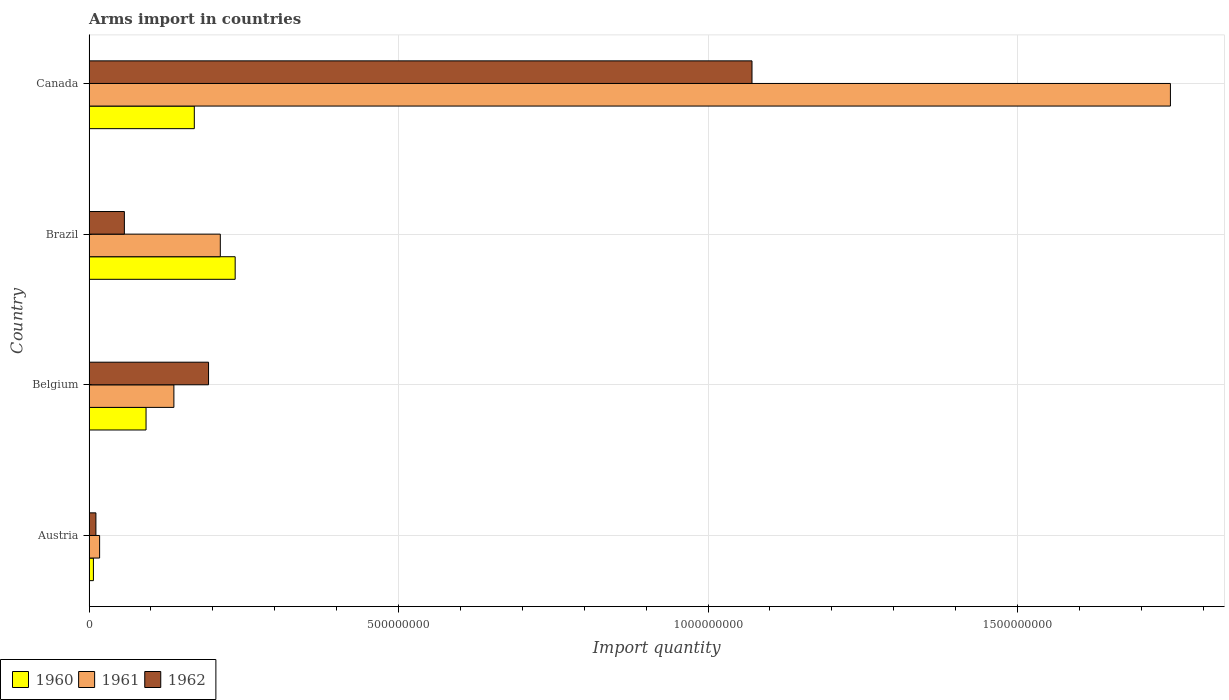How many different coloured bars are there?
Make the answer very short. 3. In how many cases, is the number of bars for a given country not equal to the number of legend labels?
Your answer should be compact. 0. What is the total arms import in 1960 in Canada?
Offer a very short reply. 1.70e+08. Across all countries, what is the maximum total arms import in 1961?
Give a very brief answer. 1.75e+09. Across all countries, what is the minimum total arms import in 1962?
Offer a very short reply. 1.10e+07. In which country was the total arms import in 1960 minimum?
Your response must be concise. Austria. What is the total total arms import in 1960 in the graph?
Provide a short and direct response. 5.05e+08. What is the difference between the total arms import in 1962 in Belgium and that in Brazil?
Your response must be concise. 1.36e+08. What is the difference between the total arms import in 1961 in Canada and the total arms import in 1962 in Austria?
Make the answer very short. 1.74e+09. What is the average total arms import in 1962 per country?
Provide a short and direct response. 3.33e+08. In how many countries, is the total arms import in 1961 greater than 700000000 ?
Keep it short and to the point. 1. What is the ratio of the total arms import in 1960 in Belgium to that in Brazil?
Give a very brief answer. 0.39. What is the difference between the highest and the second highest total arms import in 1960?
Your answer should be very brief. 6.60e+07. What is the difference between the highest and the lowest total arms import in 1961?
Your response must be concise. 1.73e+09. In how many countries, is the total arms import in 1961 greater than the average total arms import in 1961 taken over all countries?
Ensure brevity in your answer.  1. What does the 1st bar from the top in Canada represents?
Make the answer very short. 1962. Is it the case that in every country, the sum of the total arms import in 1962 and total arms import in 1961 is greater than the total arms import in 1960?
Provide a short and direct response. Yes. How many bars are there?
Keep it short and to the point. 12. Are all the bars in the graph horizontal?
Ensure brevity in your answer.  Yes. How many countries are there in the graph?
Offer a terse response. 4. What is the difference between two consecutive major ticks on the X-axis?
Keep it short and to the point. 5.00e+08. Does the graph contain grids?
Your answer should be compact. Yes. How many legend labels are there?
Keep it short and to the point. 3. What is the title of the graph?
Ensure brevity in your answer.  Arms import in countries. What is the label or title of the X-axis?
Ensure brevity in your answer.  Import quantity. What is the Import quantity in 1960 in Austria?
Offer a terse response. 7.00e+06. What is the Import quantity in 1961 in Austria?
Ensure brevity in your answer.  1.70e+07. What is the Import quantity in 1962 in Austria?
Keep it short and to the point. 1.10e+07. What is the Import quantity in 1960 in Belgium?
Ensure brevity in your answer.  9.20e+07. What is the Import quantity of 1961 in Belgium?
Your answer should be very brief. 1.37e+08. What is the Import quantity of 1962 in Belgium?
Your answer should be very brief. 1.93e+08. What is the Import quantity of 1960 in Brazil?
Your answer should be compact. 2.36e+08. What is the Import quantity of 1961 in Brazil?
Your response must be concise. 2.12e+08. What is the Import quantity of 1962 in Brazil?
Make the answer very short. 5.70e+07. What is the Import quantity of 1960 in Canada?
Your answer should be compact. 1.70e+08. What is the Import quantity of 1961 in Canada?
Provide a short and direct response. 1.75e+09. What is the Import quantity of 1962 in Canada?
Provide a short and direct response. 1.07e+09. Across all countries, what is the maximum Import quantity in 1960?
Your answer should be very brief. 2.36e+08. Across all countries, what is the maximum Import quantity of 1961?
Provide a short and direct response. 1.75e+09. Across all countries, what is the maximum Import quantity in 1962?
Provide a succinct answer. 1.07e+09. Across all countries, what is the minimum Import quantity of 1960?
Offer a very short reply. 7.00e+06. Across all countries, what is the minimum Import quantity in 1961?
Keep it short and to the point. 1.70e+07. Across all countries, what is the minimum Import quantity of 1962?
Provide a short and direct response. 1.10e+07. What is the total Import quantity of 1960 in the graph?
Your answer should be very brief. 5.05e+08. What is the total Import quantity in 1961 in the graph?
Your answer should be compact. 2.11e+09. What is the total Import quantity of 1962 in the graph?
Offer a very short reply. 1.33e+09. What is the difference between the Import quantity of 1960 in Austria and that in Belgium?
Offer a terse response. -8.50e+07. What is the difference between the Import quantity of 1961 in Austria and that in Belgium?
Offer a very short reply. -1.20e+08. What is the difference between the Import quantity in 1962 in Austria and that in Belgium?
Give a very brief answer. -1.82e+08. What is the difference between the Import quantity in 1960 in Austria and that in Brazil?
Keep it short and to the point. -2.29e+08. What is the difference between the Import quantity of 1961 in Austria and that in Brazil?
Make the answer very short. -1.95e+08. What is the difference between the Import quantity of 1962 in Austria and that in Brazil?
Your response must be concise. -4.60e+07. What is the difference between the Import quantity of 1960 in Austria and that in Canada?
Your response must be concise. -1.63e+08. What is the difference between the Import quantity in 1961 in Austria and that in Canada?
Give a very brief answer. -1.73e+09. What is the difference between the Import quantity in 1962 in Austria and that in Canada?
Make the answer very short. -1.06e+09. What is the difference between the Import quantity in 1960 in Belgium and that in Brazil?
Offer a terse response. -1.44e+08. What is the difference between the Import quantity of 1961 in Belgium and that in Brazil?
Provide a short and direct response. -7.50e+07. What is the difference between the Import quantity of 1962 in Belgium and that in Brazil?
Offer a terse response. 1.36e+08. What is the difference between the Import quantity of 1960 in Belgium and that in Canada?
Give a very brief answer. -7.80e+07. What is the difference between the Import quantity of 1961 in Belgium and that in Canada?
Offer a terse response. -1.61e+09. What is the difference between the Import quantity of 1962 in Belgium and that in Canada?
Offer a terse response. -8.78e+08. What is the difference between the Import quantity in 1960 in Brazil and that in Canada?
Your response must be concise. 6.60e+07. What is the difference between the Import quantity in 1961 in Brazil and that in Canada?
Provide a short and direct response. -1.54e+09. What is the difference between the Import quantity in 1962 in Brazil and that in Canada?
Your response must be concise. -1.01e+09. What is the difference between the Import quantity of 1960 in Austria and the Import quantity of 1961 in Belgium?
Offer a very short reply. -1.30e+08. What is the difference between the Import quantity of 1960 in Austria and the Import quantity of 1962 in Belgium?
Provide a short and direct response. -1.86e+08. What is the difference between the Import quantity in 1961 in Austria and the Import quantity in 1962 in Belgium?
Provide a succinct answer. -1.76e+08. What is the difference between the Import quantity of 1960 in Austria and the Import quantity of 1961 in Brazil?
Provide a succinct answer. -2.05e+08. What is the difference between the Import quantity in 1960 in Austria and the Import quantity in 1962 in Brazil?
Your answer should be compact. -5.00e+07. What is the difference between the Import quantity in 1961 in Austria and the Import quantity in 1962 in Brazil?
Offer a very short reply. -4.00e+07. What is the difference between the Import quantity in 1960 in Austria and the Import quantity in 1961 in Canada?
Make the answer very short. -1.74e+09. What is the difference between the Import quantity in 1960 in Austria and the Import quantity in 1962 in Canada?
Ensure brevity in your answer.  -1.06e+09. What is the difference between the Import quantity of 1961 in Austria and the Import quantity of 1962 in Canada?
Provide a short and direct response. -1.05e+09. What is the difference between the Import quantity in 1960 in Belgium and the Import quantity in 1961 in Brazil?
Give a very brief answer. -1.20e+08. What is the difference between the Import quantity in 1960 in Belgium and the Import quantity in 1962 in Brazil?
Offer a very short reply. 3.50e+07. What is the difference between the Import quantity of 1961 in Belgium and the Import quantity of 1962 in Brazil?
Provide a short and direct response. 8.00e+07. What is the difference between the Import quantity of 1960 in Belgium and the Import quantity of 1961 in Canada?
Your answer should be very brief. -1.66e+09. What is the difference between the Import quantity of 1960 in Belgium and the Import quantity of 1962 in Canada?
Provide a succinct answer. -9.79e+08. What is the difference between the Import quantity of 1961 in Belgium and the Import quantity of 1962 in Canada?
Your answer should be compact. -9.34e+08. What is the difference between the Import quantity of 1960 in Brazil and the Import quantity of 1961 in Canada?
Offer a terse response. -1.51e+09. What is the difference between the Import quantity of 1960 in Brazil and the Import quantity of 1962 in Canada?
Your answer should be very brief. -8.35e+08. What is the difference between the Import quantity in 1961 in Brazil and the Import quantity in 1962 in Canada?
Make the answer very short. -8.59e+08. What is the average Import quantity of 1960 per country?
Your answer should be compact. 1.26e+08. What is the average Import quantity in 1961 per country?
Provide a short and direct response. 5.28e+08. What is the average Import quantity of 1962 per country?
Your answer should be very brief. 3.33e+08. What is the difference between the Import quantity in 1960 and Import quantity in 1961 in Austria?
Keep it short and to the point. -1.00e+07. What is the difference between the Import quantity of 1961 and Import quantity of 1962 in Austria?
Your answer should be compact. 6.00e+06. What is the difference between the Import quantity of 1960 and Import quantity of 1961 in Belgium?
Provide a succinct answer. -4.50e+07. What is the difference between the Import quantity in 1960 and Import quantity in 1962 in Belgium?
Your response must be concise. -1.01e+08. What is the difference between the Import quantity of 1961 and Import quantity of 1962 in Belgium?
Ensure brevity in your answer.  -5.60e+07. What is the difference between the Import quantity of 1960 and Import quantity of 1961 in Brazil?
Offer a very short reply. 2.40e+07. What is the difference between the Import quantity of 1960 and Import quantity of 1962 in Brazil?
Your answer should be compact. 1.79e+08. What is the difference between the Import quantity in 1961 and Import quantity in 1962 in Brazil?
Offer a very short reply. 1.55e+08. What is the difference between the Import quantity in 1960 and Import quantity in 1961 in Canada?
Offer a terse response. -1.58e+09. What is the difference between the Import quantity in 1960 and Import quantity in 1962 in Canada?
Provide a succinct answer. -9.01e+08. What is the difference between the Import quantity in 1961 and Import quantity in 1962 in Canada?
Offer a terse response. 6.76e+08. What is the ratio of the Import quantity in 1960 in Austria to that in Belgium?
Your response must be concise. 0.08. What is the ratio of the Import quantity in 1961 in Austria to that in Belgium?
Make the answer very short. 0.12. What is the ratio of the Import quantity in 1962 in Austria to that in Belgium?
Provide a short and direct response. 0.06. What is the ratio of the Import quantity in 1960 in Austria to that in Brazil?
Provide a succinct answer. 0.03. What is the ratio of the Import quantity of 1961 in Austria to that in Brazil?
Provide a succinct answer. 0.08. What is the ratio of the Import quantity in 1962 in Austria to that in Brazil?
Give a very brief answer. 0.19. What is the ratio of the Import quantity of 1960 in Austria to that in Canada?
Your response must be concise. 0.04. What is the ratio of the Import quantity in 1961 in Austria to that in Canada?
Give a very brief answer. 0.01. What is the ratio of the Import quantity in 1962 in Austria to that in Canada?
Offer a terse response. 0.01. What is the ratio of the Import quantity in 1960 in Belgium to that in Brazil?
Keep it short and to the point. 0.39. What is the ratio of the Import quantity of 1961 in Belgium to that in Brazil?
Offer a terse response. 0.65. What is the ratio of the Import quantity in 1962 in Belgium to that in Brazil?
Provide a succinct answer. 3.39. What is the ratio of the Import quantity in 1960 in Belgium to that in Canada?
Your answer should be very brief. 0.54. What is the ratio of the Import quantity in 1961 in Belgium to that in Canada?
Your response must be concise. 0.08. What is the ratio of the Import quantity of 1962 in Belgium to that in Canada?
Your answer should be very brief. 0.18. What is the ratio of the Import quantity of 1960 in Brazil to that in Canada?
Your answer should be very brief. 1.39. What is the ratio of the Import quantity of 1961 in Brazil to that in Canada?
Offer a very short reply. 0.12. What is the ratio of the Import quantity of 1962 in Brazil to that in Canada?
Provide a short and direct response. 0.05. What is the difference between the highest and the second highest Import quantity of 1960?
Offer a very short reply. 6.60e+07. What is the difference between the highest and the second highest Import quantity of 1961?
Your answer should be very brief. 1.54e+09. What is the difference between the highest and the second highest Import quantity in 1962?
Provide a succinct answer. 8.78e+08. What is the difference between the highest and the lowest Import quantity in 1960?
Make the answer very short. 2.29e+08. What is the difference between the highest and the lowest Import quantity in 1961?
Ensure brevity in your answer.  1.73e+09. What is the difference between the highest and the lowest Import quantity of 1962?
Your answer should be very brief. 1.06e+09. 